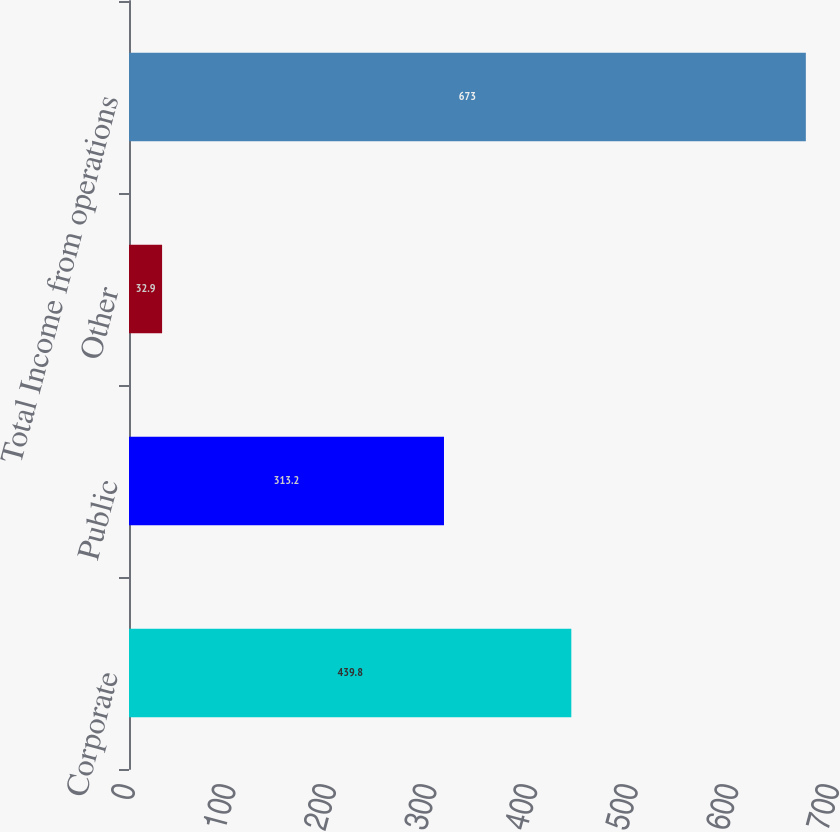Convert chart. <chart><loc_0><loc_0><loc_500><loc_500><bar_chart><fcel>Corporate<fcel>Public<fcel>Other<fcel>Total Income from operations<nl><fcel>439.8<fcel>313.2<fcel>32.9<fcel>673<nl></chart> 